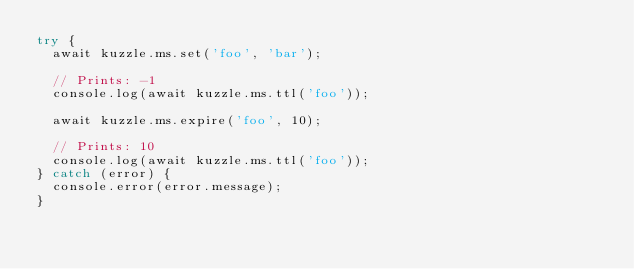<code> <loc_0><loc_0><loc_500><loc_500><_JavaScript_>try {
  await kuzzle.ms.set('foo', 'bar');

  // Prints: -1
  console.log(await kuzzle.ms.ttl('foo'));

  await kuzzle.ms.expire('foo', 10);

  // Prints: 10
  console.log(await kuzzle.ms.ttl('foo'));
} catch (error) {
  console.error(error.message);
}
</code> 